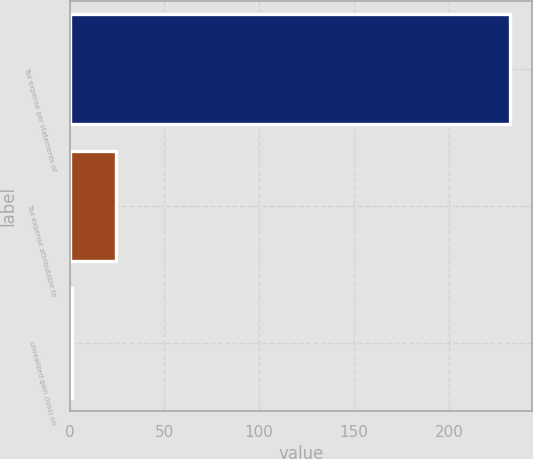Convert chart. <chart><loc_0><loc_0><loc_500><loc_500><bar_chart><fcel>Tax expense per statements of<fcel>Tax expense attributable to<fcel>Unrealized gain (loss) on<nl><fcel>232.4<fcel>24.59<fcel>1.5<nl></chart> 